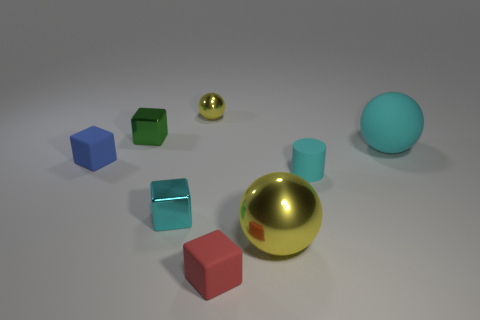Are there the same number of cylinders that are in front of the red matte block and shiny blocks to the left of the cyan metal thing?
Provide a succinct answer. No. Is the shape of the tiny yellow object the same as the tiny object that is on the right side of the red cube?
Your response must be concise. No. How many other objects are the same material as the green cube?
Your response must be concise. 3. There is a small cyan matte thing; are there any small green metallic blocks in front of it?
Provide a succinct answer. No. There is a red matte cube; is its size the same as the ball that is behind the large cyan sphere?
Your answer should be compact. Yes. There is a matte object left of the tiny shiny block in front of the tiny blue thing; what color is it?
Your response must be concise. Blue. Do the cyan cylinder and the cyan matte sphere have the same size?
Give a very brief answer. No. What is the color of the thing that is both behind the blue thing and to the right of the tiny metal sphere?
Give a very brief answer. Cyan. How big is the cyan cylinder?
Ensure brevity in your answer.  Small. There is a metal block that is in front of the tiny blue rubber cube; is it the same color as the big matte object?
Your answer should be compact. Yes. 